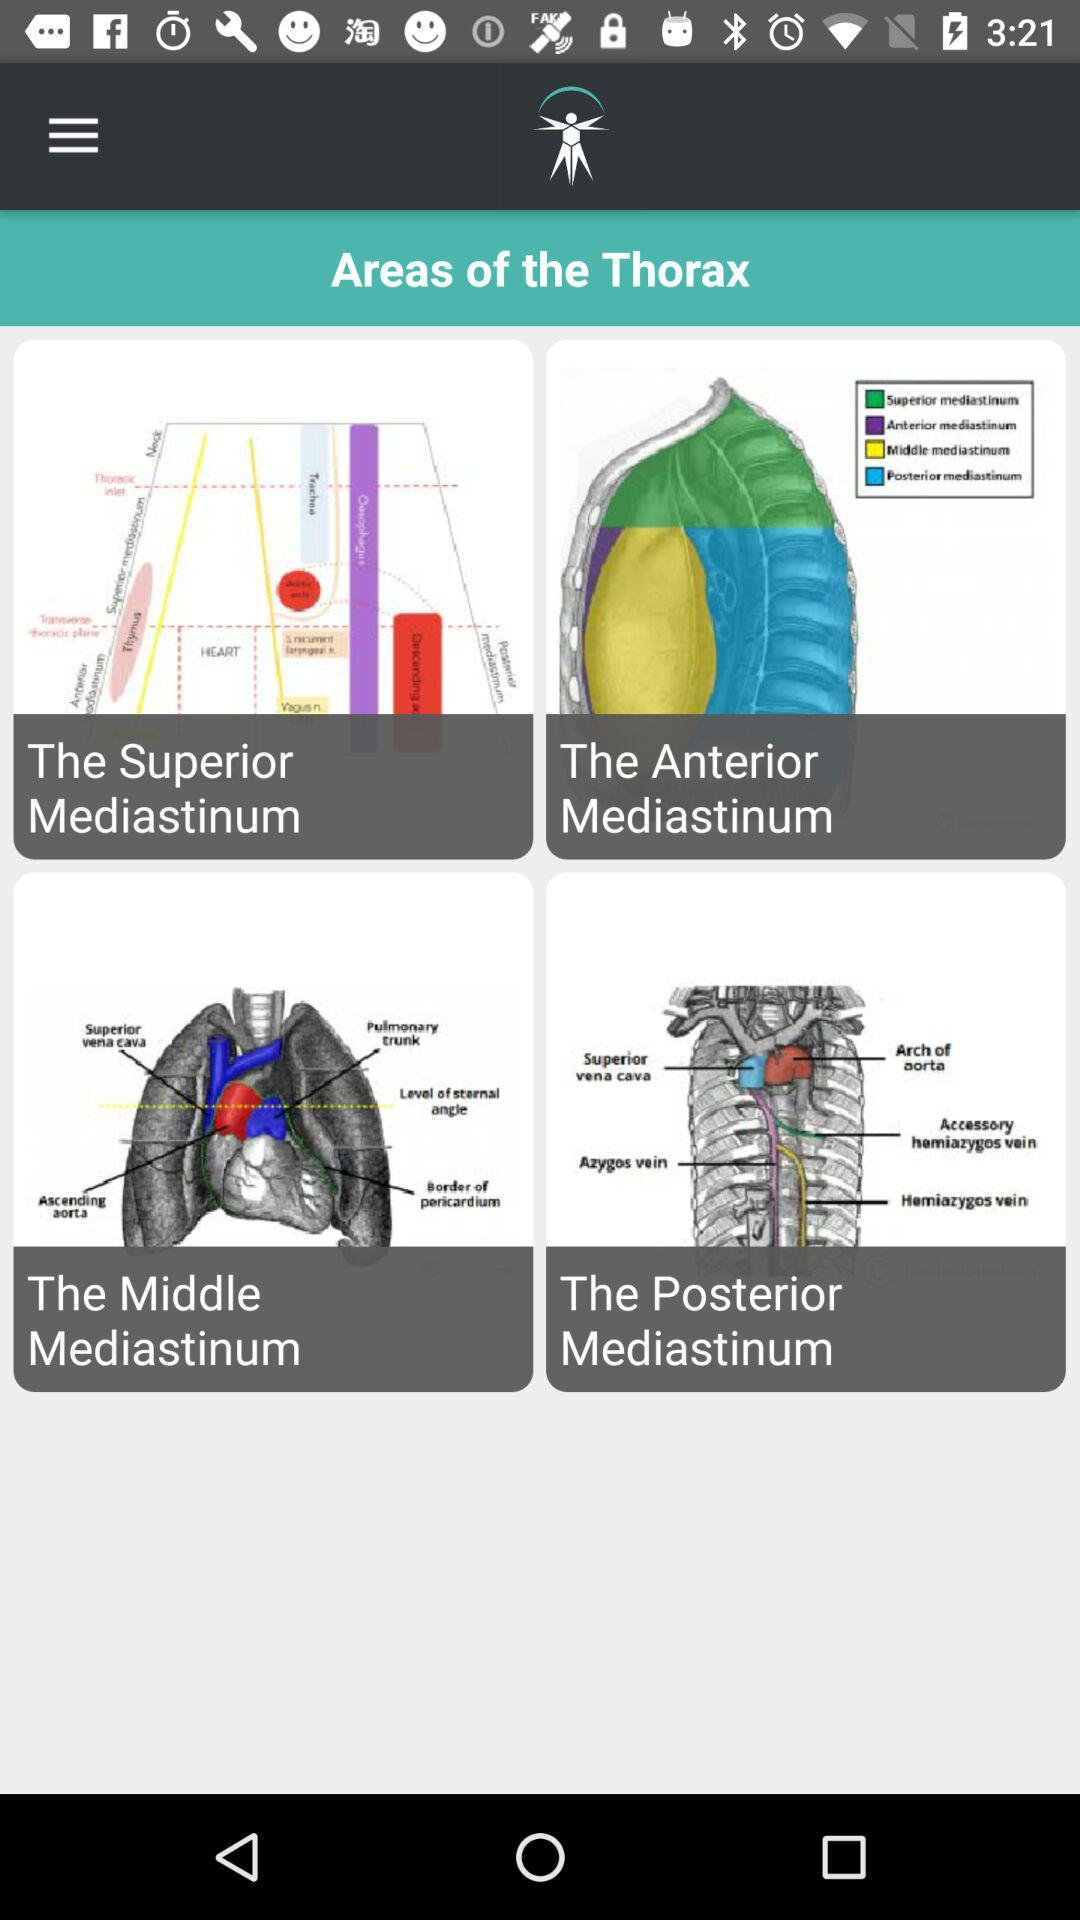How many areas of the thorax are there?
Answer the question using a single word or phrase. 4 